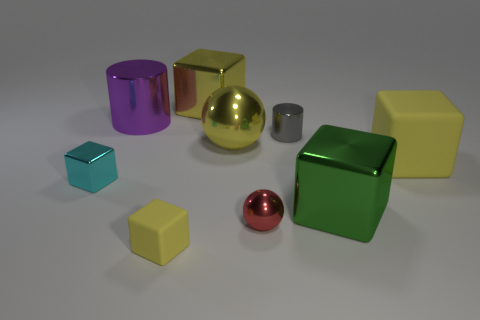What number of cylinders are small blue rubber things or gray things?
Your answer should be compact. 1. Are there any big cylinders?
Make the answer very short. Yes. Are there any other things that are the same shape as the big green thing?
Your response must be concise. Yes. Is the tiny shiny sphere the same color as the big metallic cylinder?
Offer a terse response. No. What number of objects are green objects that are right of the cyan metal object or large brown matte cylinders?
Offer a terse response. 1. There is a cylinder to the left of the sphere behind the cyan cube; how many big yellow shiny things are in front of it?
Keep it short and to the point. 1. Are there any other things that have the same size as the gray cylinder?
Offer a very short reply. Yes. The large object that is left of the big yellow block that is behind the large object to the left of the tiny yellow matte thing is what shape?
Your answer should be compact. Cylinder. What number of other objects are the same color as the tiny rubber block?
Your answer should be compact. 3. The red metal thing that is in front of the ball that is behind the small ball is what shape?
Ensure brevity in your answer.  Sphere. 